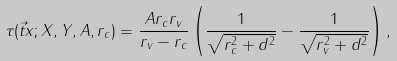<formula> <loc_0><loc_0><loc_500><loc_500>\tau ( \vec { t } { x } ; X , Y , A , r _ { c } ) = \frac { A r _ { c } r _ { v } } { r _ { v } - r _ { c } } \left ( \frac { 1 } { \sqrt { r _ { c } ^ { 2 } + d ^ { 2 } } } - \frac { 1 } { \sqrt { r _ { v } ^ { 2 } + d ^ { 2 } } } \right ) ,</formula> 